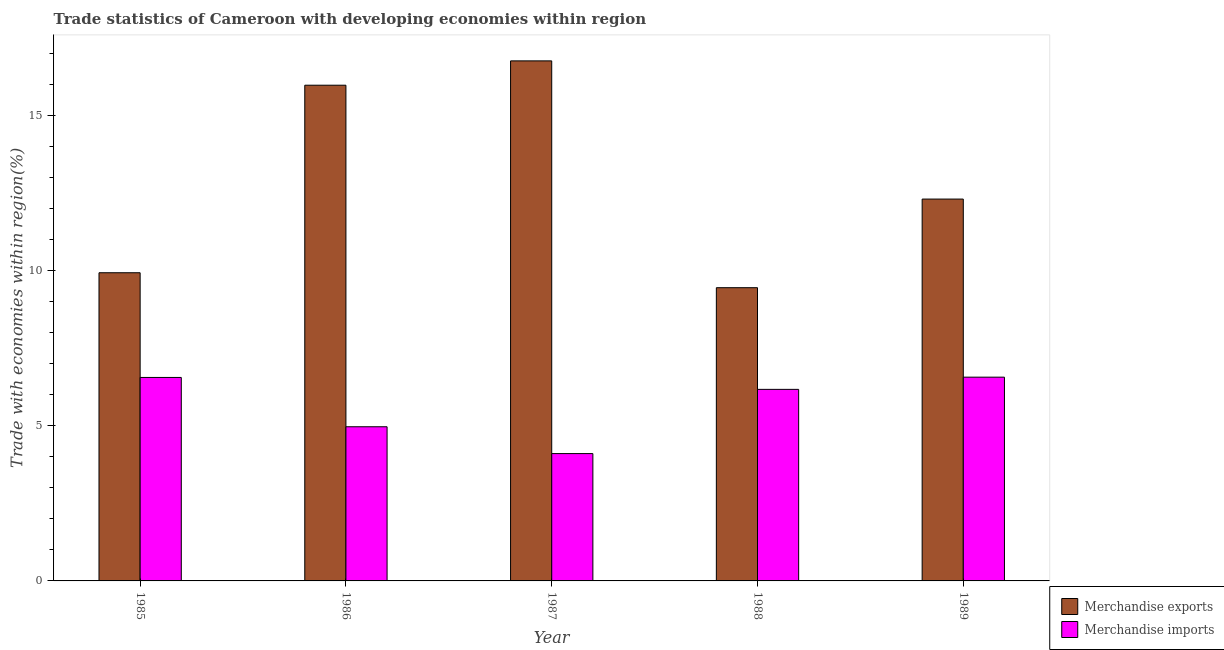How many different coloured bars are there?
Keep it short and to the point. 2. Are the number of bars per tick equal to the number of legend labels?
Provide a succinct answer. Yes. Are the number of bars on each tick of the X-axis equal?
Keep it short and to the point. Yes. What is the label of the 3rd group of bars from the left?
Offer a terse response. 1987. What is the merchandise imports in 1988?
Keep it short and to the point. 6.17. Across all years, what is the maximum merchandise imports?
Offer a very short reply. 6.56. Across all years, what is the minimum merchandise exports?
Your response must be concise. 9.44. In which year was the merchandise imports maximum?
Your response must be concise. 1989. In which year was the merchandise imports minimum?
Offer a terse response. 1987. What is the total merchandise exports in the graph?
Ensure brevity in your answer.  64.37. What is the difference between the merchandise exports in 1987 and that in 1988?
Your answer should be compact. 7.3. What is the difference between the merchandise imports in 1985 and the merchandise exports in 1989?
Provide a short and direct response. -0.01. What is the average merchandise exports per year?
Provide a short and direct response. 12.87. What is the ratio of the merchandise imports in 1985 to that in 1989?
Make the answer very short. 1. Is the merchandise exports in 1986 less than that in 1988?
Your answer should be very brief. No. Is the difference between the merchandise imports in 1987 and 1988 greater than the difference between the merchandise exports in 1987 and 1988?
Provide a succinct answer. No. What is the difference between the highest and the second highest merchandise imports?
Your answer should be compact. 0.01. What is the difference between the highest and the lowest merchandise exports?
Give a very brief answer. 7.3. Is the sum of the merchandise imports in 1986 and 1987 greater than the maximum merchandise exports across all years?
Make the answer very short. Yes. What does the 1st bar from the left in 1986 represents?
Your response must be concise. Merchandise exports. How many bars are there?
Keep it short and to the point. 10. Are all the bars in the graph horizontal?
Make the answer very short. No. How many years are there in the graph?
Offer a terse response. 5. What is the difference between two consecutive major ticks on the Y-axis?
Give a very brief answer. 5. Are the values on the major ticks of Y-axis written in scientific E-notation?
Your answer should be very brief. No. Does the graph contain grids?
Your response must be concise. No. How many legend labels are there?
Provide a succinct answer. 2. How are the legend labels stacked?
Your response must be concise. Vertical. What is the title of the graph?
Provide a succinct answer. Trade statistics of Cameroon with developing economies within region. What is the label or title of the X-axis?
Make the answer very short. Year. What is the label or title of the Y-axis?
Provide a succinct answer. Trade with economies within region(%). What is the Trade with economies within region(%) in Merchandise exports in 1985?
Give a very brief answer. 9.92. What is the Trade with economies within region(%) in Merchandise imports in 1985?
Provide a short and direct response. 6.55. What is the Trade with economies within region(%) in Merchandise exports in 1986?
Provide a succinct answer. 15.96. What is the Trade with economies within region(%) in Merchandise imports in 1986?
Provide a succinct answer. 4.96. What is the Trade with economies within region(%) of Merchandise exports in 1987?
Provide a short and direct response. 16.75. What is the Trade with economies within region(%) in Merchandise imports in 1987?
Provide a short and direct response. 4.1. What is the Trade with economies within region(%) in Merchandise exports in 1988?
Keep it short and to the point. 9.44. What is the Trade with economies within region(%) in Merchandise imports in 1988?
Ensure brevity in your answer.  6.17. What is the Trade with economies within region(%) in Merchandise exports in 1989?
Offer a terse response. 12.3. What is the Trade with economies within region(%) in Merchandise imports in 1989?
Provide a short and direct response. 6.56. Across all years, what is the maximum Trade with economies within region(%) of Merchandise exports?
Give a very brief answer. 16.75. Across all years, what is the maximum Trade with economies within region(%) of Merchandise imports?
Your response must be concise. 6.56. Across all years, what is the minimum Trade with economies within region(%) in Merchandise exports?
Offer a very short reply. 9.44. Across all years, what is the minimum Trade with economies within region(%) of Merchandise imports?
Your answer should be compact. 4.1. What is the total Trade with economies within region(%) of Merchandise exports in the graph?
Make the answer very short. 64.37. What is the total Trade with economies within region(%) of Merchandise imports in the graph?
Provide a short and direct response. 28.35. What is the difference between the Trade with economies within region(%) of Merchandise exports in 1985 and that in 1986?
Your response must be concise. -6.04. What is the difference between the Trade with economies within region(%) in Merchandise imports in 1985 and that in 1986?
Ensure brevity in your answer.  1.59. What is the difference between the Trade with economies within region(%) in Merchandise exports in 1985 and that in 1987?
Your answer should be compact. -6.82. What is the difference between the Trade with economies within region(%) in Merchandise imports in 1985 and that in 1987?
Provide a short and direct response. 2.45. What is the difference between the Trade with economies within region(%) in Merchandise exports in 1985 and that in 1988?
Make the answer very short. 0.48. What is the difference between the Trade with economies within region(%) of Merchandise imports in 1985 and that in 1988?
Make the answer very short. 0.38. What is the difference between the Trade with economies within region(%) of Merchandise exports in 1985 and that in 1989?
Your answer should be compact. -2.37. What is the difference between the Trade with economies within region(%) of Merchandise imports in 1985 and that in 1989?
Your response must be concise. -0.01. What is the difference between the Trade with economies within region(%) of Merchandise exports in 1986 and that in 1987?
Your answer should be compact. -0.78. What is the difference between the Trade with economies within region(%) in Merchandise imports in 1986 and that in 1987?
Offer a very short reply. 0.86. What is the difference between the Trade with economies within region(%) in Merchandise exports in 1986 and that in 1988?
Your response must be concise. 6.52. What is the difference between the Trade with economies within region(%) in Merchandise imports in 1986 and that in 1988?
Make the answer very short. -1.2. What is the difference between the Trade with economies within region(%) in Merchandise exports in 1986 and that in 1989?
Make the answer very short. 3.67. What is the difference between the Trade with economies within region(%) of Merchandise imports in 1986 and that in 1989?
Provide a short and direct response. -1.6. What is the difference between the Trade with economies within region(%) in Merchandise exports in 1987 and that in 1988?
Provide a succinct answer. 7.3. What is the difference between the Trade with economies within region(%) of Merchandise imports in 1987 and that in 1988?
Your response must be concise. -2.07. What is the difference between the Trade with economies within region(%) of Merchandise exports in 1987 and that in 1989?
Your answer should be very brief. 4.45. What is the difference between the Trade with economies within region(%) in Merchandise imports in 1987 and that in 1989?
Make the answer very short. -2.46. What is the difference between the Trade with economies within region(%) of Merchandise exports in 1988 and that in 1989?
Your response must be concise. -2.85. What is the difference between the Trade with economies within region(%) of Merchandise imports in 1988 and that in 1989?
Provide a succinct answer. -0.39. What is the difference between the Trade with economies within region(%) in Merchandise exports in 1985 and the Trade with economies within region(%) in Merchandise imports in 1986?
Offer a very short reply. 4.96. What is the difference between the Trade with economies within region(%) in Merchandise exports in 1985 and the Trade with economies within region(%) in Merchandise imports in 1987?
Offer a very short reply. 5.82. What is the difference between the Trade with economies within region(%) in Merchandise exports in 1985 and the Trade with economies within region(%) in Merchandise imports in 1988?
Make the answer very short. 3.76. What is the difference between the Trade with economies within region(%) of Merchandise exports in 1985 and the Trade with economies within region(%) of Merchandise imports in 1989?
Give a very brief answer. 3.36. What is the difference between the Trade with economies within region(%) in Merchandise exports in 1986 and the Trade with economies within region(%) in Merchandise imports in 1987?
Make the answer very short. 11.86. What is the difference between the Trade with economies within region(%) in Merchandise exports in 1986 and the Trade with economies within region(%) in Merchandise imports in 1988?
Make the answer very short. 9.79. What is the difference between the Trade with economies within region(%) of Merchandise exports in 1986 and the Trade with economies within region(%) of Merchandise imports in 1989?
Your answer should be compact. 9.4. What is the difference between the Trade with economies within region(%) of Merchandise exports in 1987 and the Trade with economies within region(%) of Merchandise imports in 1988?
Ensure brevity in your answer.  10.58. What is the difference between the Trade with economies within region(%) in Merchandise exports in 1987 and the Trade with economies within region(%) in Merchandise imports in 1989?
Give a very brief answer. 10.19. What is the difference between the Trade with economies within region(%) in Merchandise exports in 1988 and the Trade with economies within region(%) in Merchandise imports in 1989?
Provide a short and direct response. 2.88. What is the average Trade with economies within region(%) of Merchandise exports per year?
Offer a terse response. 12.87. What is the average Trade with economies within region(%) in Merchandise imports per year?
Provide a short and direct response. 5.67. In the year 1985, what is the difference between the Trade with economies within region(%) of Merchandise exports and Trade with economies within region(%) of Merchandise imports?
Your response must be concise. 3.37. In the year 1986, what is the difference between the Trade with economies within region(%) in Merchandise exports and Trade with economies within region(%) in Merchandise imports?
Your answer should be compact. 11. In the year 1987, what is the difference between the Trade with economies within region(%) in Merchandise exports and Trade with economies within region(%) in Merchandise imports?
Make the answer very short. 12.65. In the year 1988, what is the difference between the Trade with economies within region(%) of Merchandise exports and Trade with economies within region(%) of Merchandise imports?
Your answer should be very brief. 3.27. In the year 1989, what is the difference between the Trade with economies within region(%) of Merchandise exports and Trade with economies within region(%) of Merchandise imports?
Ensure brevity in your answer.  5.73. What is the ratio of the Trade with economies within region(%) of Merchandise exports in 1985 to that in 1986?
Offer a very short reply. 0.62. What is the ratio of the Trade with economies within region(%) of Merchandise imports in 1985 to that in 1986?
Keep it short and to the point. 1.32. What is the ratio of the Trade with economies within region(%) in Merchandise exports in 1985 to that in 1987?
Provide a succinct answer. 0.59. What is the ratio of the Trade with economies within region(%) in Merchandise imports in 1985 to that in 1987?
Give a very brief answer. 1.6. What is the ratio of the Trade with economies within region(%) in Merchandise exports in 1985 to that in 1988?
Provide a succinct answer. 1.05. What is the ratio of the Trade with economies within region(%) of Merchandise imports in 1985 to that in 1988?
Provide a succinct answer. 1.06. What is the ratio of the Trade with economies within region(%) in Merchandise exports in 1985 to that in 1989?
Your response must be concise. 0.81. What is the ratio of the Trade with economies within region(%) in Merchandise exports in 1986 to that in 1987?
Make the answer very short. 0.95. What is the ratio of the Trade with economies within region(%) in Merchandise imports in 1986 to that in 1987?
Offer a terse response. 1.21. What is the ratio of the Trade with economies within region(%) in Merchandise exports in 1986 to that in 1988?
Ensure brevity in your answer.  1.69. What is the ratio of the Trade with economies within region(%) of Merchandise imports in 1986 to that in 1988?
Your response must be concise. 0.8. What is the ratio of the Trade with economies within region(%) of Merchandise exports in 1986 to that in 1989?
Your response must be concise. 1.3. What is the ratio of the Trade with economies within region(%) in Merchandise imports in 1986 to that in 1989?
Your answer should be very brief. 0.76. What is the ratio of the Trade with economies within region(%) of Merchandise exports in 1987 to that in 1988?
Provide a succinct answer. 1.77. What is the ratio of the Trade with economies within region(%) in Merchandise imports in 1987 to that in 1988?
Give a very brief answer. 0.66. What is the ratio of the Trade with economies within region(%) in Merchandise exports in 1987 to that in 1989?
Your answer should be very brief. 1.36. What is the ratio of the Trade with economies within region(%) of Merchandise exports in 1988 to that in 1989?
Ensure brevity in your answer.  0.77. What is the ratio of the Trade with economies within region(%) in Merchandise imports in 1988 to that in 1989?
Keep it short and to the point. 0.94. What is the difference between the highest and the second highest Trade with economies within region(%) of Merchandise exports?
Offer a terse response. 0.78. What is the difference between the highest and the second highest Trade with economies within region(%) in Merchandise imports?
Ensure brevity in your answer.  0.01. What is the difference between the highest and the lowest Trade with economies within region(%) in Merchandise exports?
Provide a succinct answer. 7.3. What is the difference between the highest and the lowest Trade with economies within region(%) in Merchandise imports?
Provide a succinct answer. 2.46. 